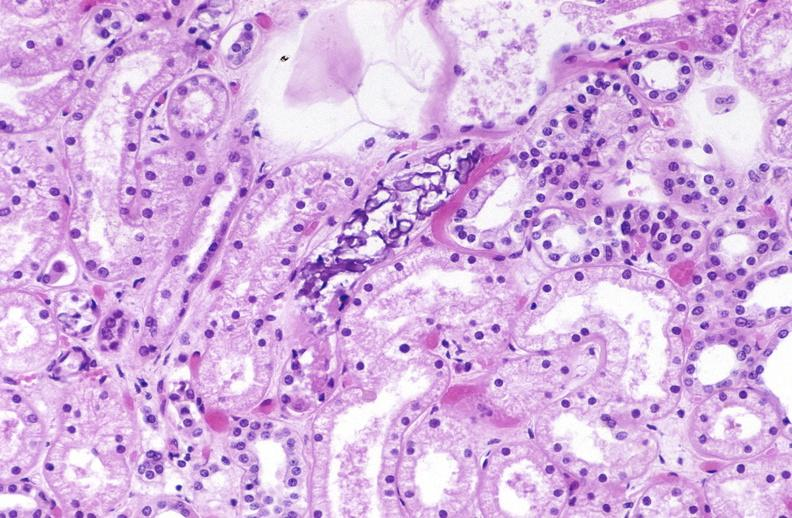what does this image show?
Answer the question using a single word or phrase. Atn and calcium deposits 